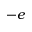<formula> <loc_0><loc_0><loc_500><loc_500>- e</formula> 